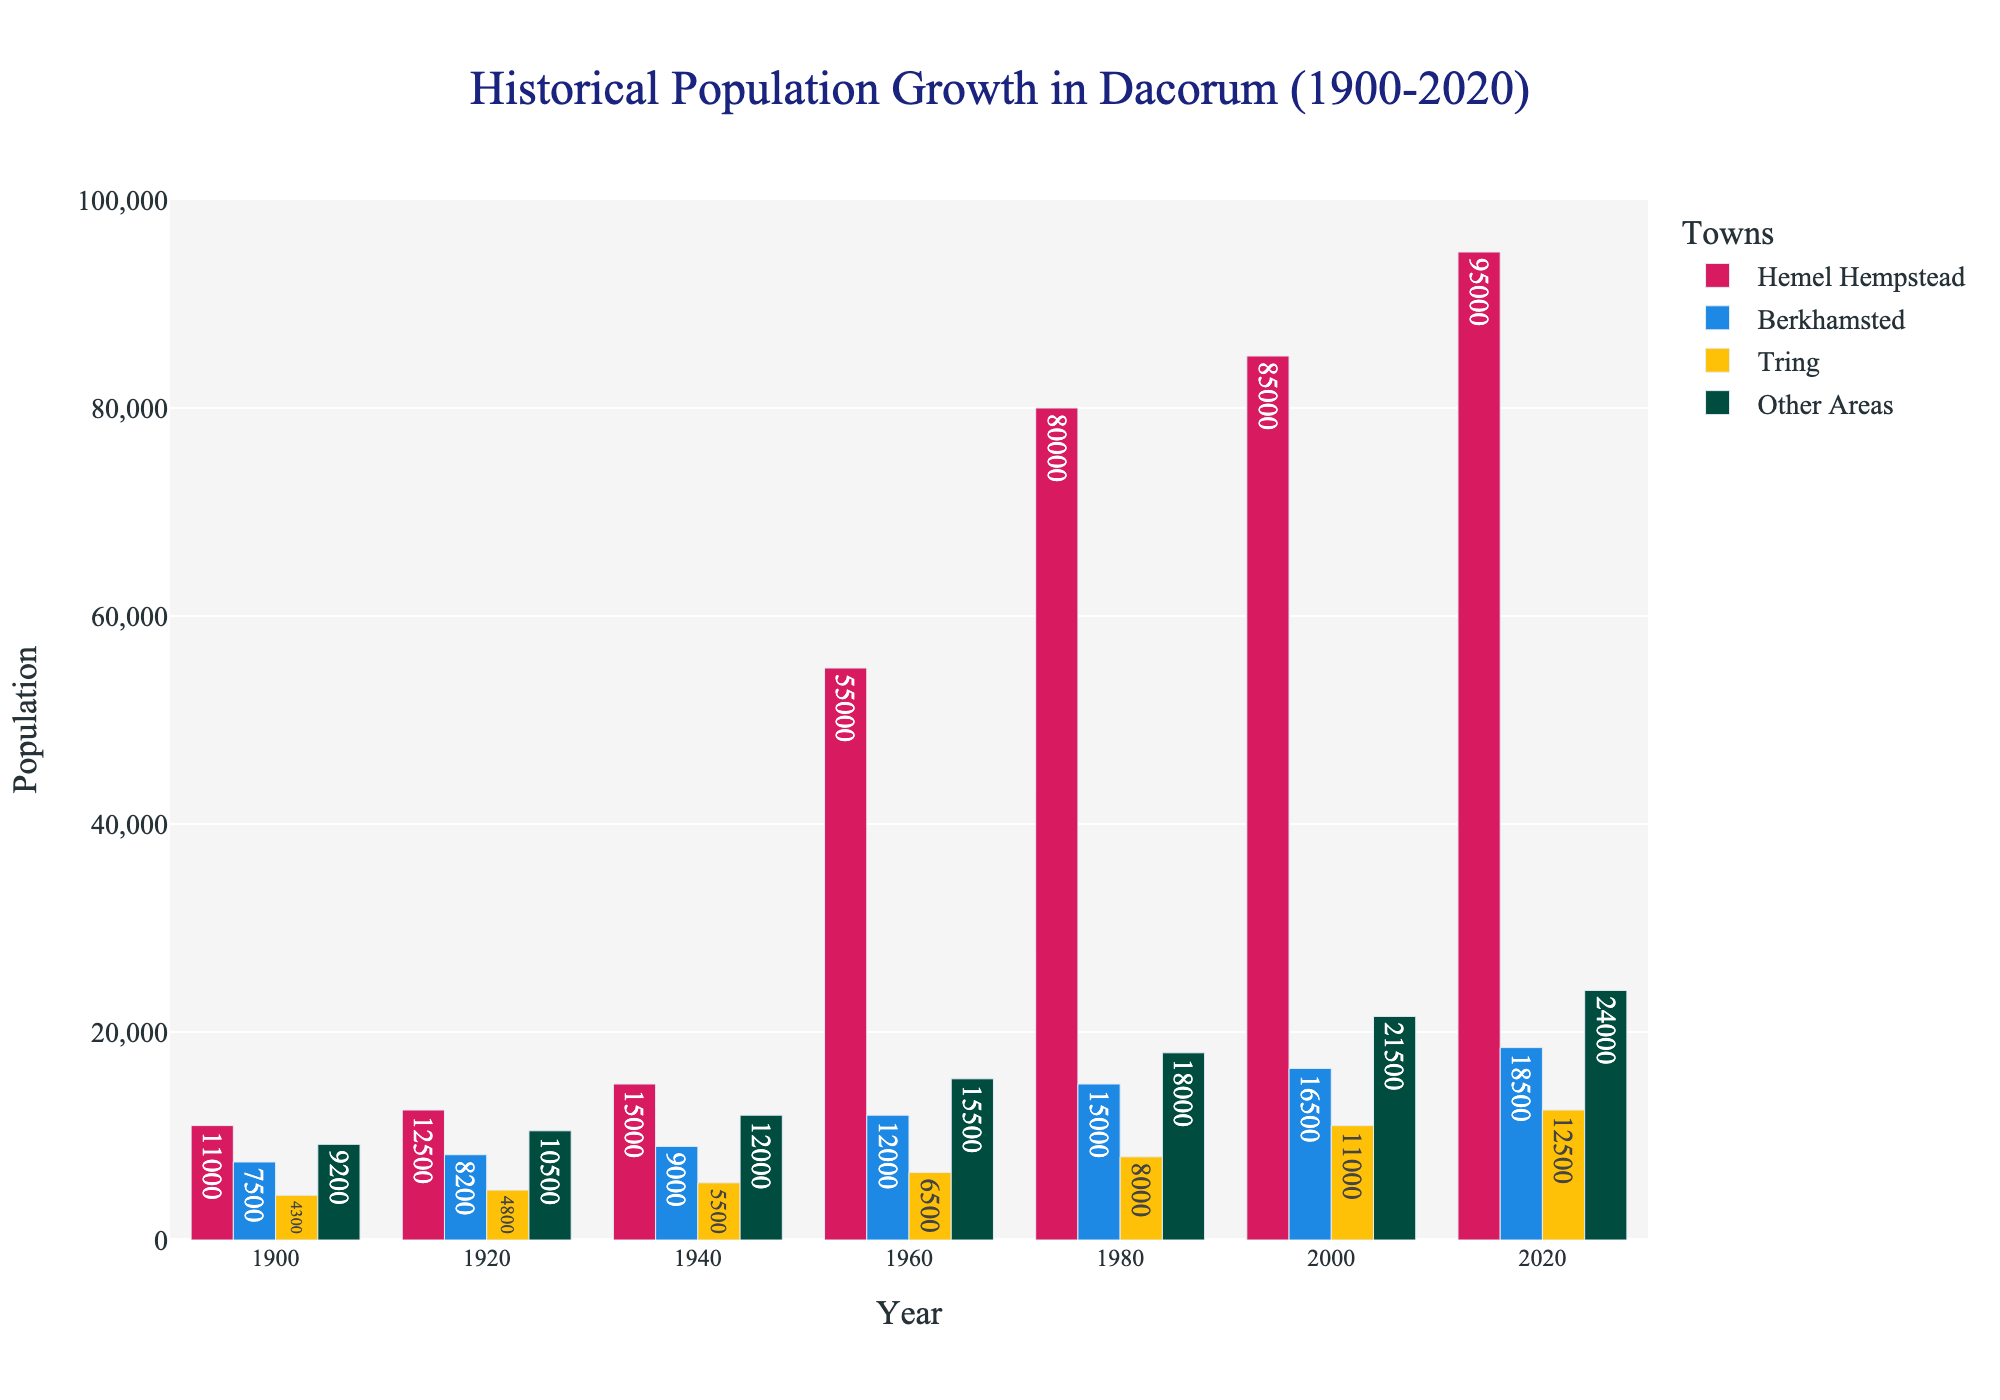Which town had the highest population in 2020? The bar representing Hemel Hempstead in 2020 is the tallest, indicating it had the highest population.
Answer: Hemel Hempstead What was the population difference between Hemel Hempstead and Tring in 2000? In 2000, Hemel Hempstead's population was 85,000, and Tring's was 11,000. Subtracting these values (85,000 - 11,000) gives the difference.
Answer: 74,000 How did the population of Berkhamsted change from 1940 to 1980? In 1940, Berkhamsted had a population of 9,000, and in 1980 it was 15,000. Subtracting the two values shows the change (15,000 - 9,000).
Answer: Increase of 6,000 Which two towns had the smallest population growth from 1920 to 2020? Comparing the population differences for all towns from 1920 to 2020, Tring grew from 4,800 to 12,500 (7,700) and Berkhamsted from 8,200 to 18,500 (10,300). Tring and Berkhamsted had the smallest population growth.
Answer: Tring and Berkhamsted In which decade did Hemel Hempstead experience the most significant population growth? Comparing Hemel Hempstead's population across decades, the jump from 1960 (55,000) to 1980 (80,000) is the largest.
Answer: 1960 to 1980 What was the total population of all areas in Dacorum in 1940? Summing the populations of all areas in 1940: Hemel Hempstead (15,000), Berkhamsted (9,000), Tring (5,500), Other Areas (12,000). Calculating 15,000 + 9,000 + 5,500 + 12,000 = 41,500
Answer: 41,500 Which area had the least population in 1900? The shortest bar in 1900 represents Tring, indicating it had the least population.
Answer: Tring How did the population of 'Other Areas' change from 1980 to 2020? In 1980, 'Other Areas' had a population of 18,000, and in 2020 it was 24,000. Subtracting these values (24,000 - 18,000) gives the change.
Answer: Increase of 6,000 What is the combined population of all towns except Hemel Hempstead in 2020? In 2020, the populations were: Berkhamsted (18,500), Tring (12,500), Other Areas (24,000). Summing these values (18,500 + 12,500 + 24,000) gives the combined population.
Answer: 55,000 Compared to its 1900 population, by how much did Hemel Hempstead grow by 2020? Hemel Hempstead's population in 1900 was 11,000, and in 2020 it was 95,000. Subtracting these values (95,000 - 11,000) shows the growth.
Answer: Increase of 84,000 